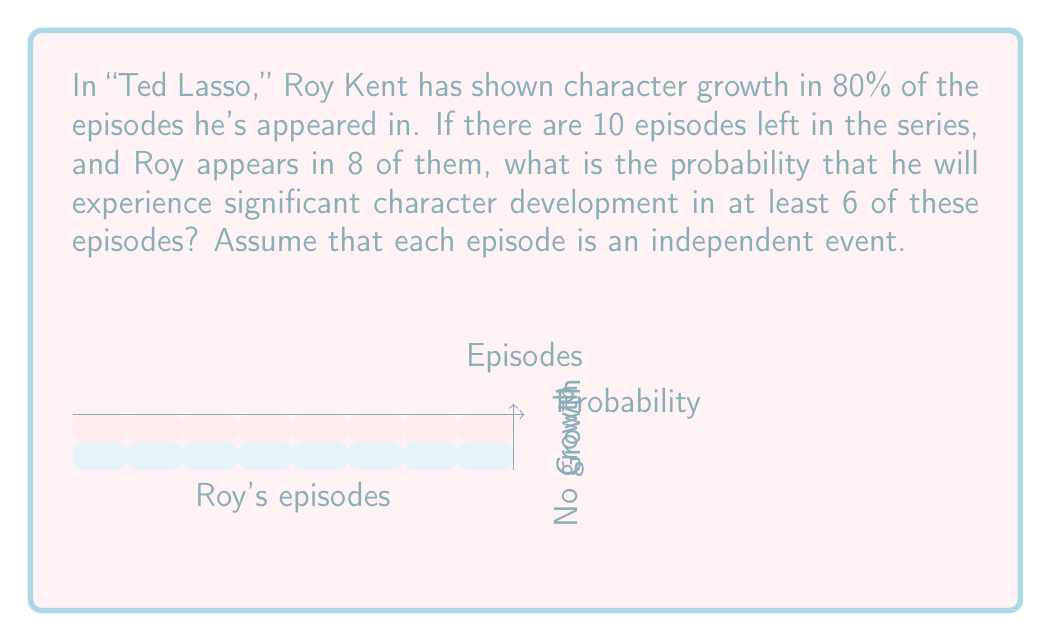Help me with this question. Let's approach this step-by-step using the Binomial distribution:

1) We're dealing with a binomial probability problem where:
   - $n = 8$ (number of episodes Roy appears in)
   - $p = 0.8$ (probability of character growth in each episode)
   - We want at least 6 successes, so we need to calculate $P(X \geq 6)$

2) The probability of at least 6 successes is equal to 1 minus the probability of 5 or fewer successes:

   $P(X \geq 6) = 1 - P(X \leq 5)$

3) Using the binomial probability formula:

   $P(X = k) = \binom{n}{k} p^k (1-p)^{n-k}$

4) We need to sum this for $k = 0$ to $5$:

   $P(X \leq 5) = \sum_{k=0}^5 \binom{8}{k} (0.8)^k (0.2)^{8-k}$

5) Calculating each term:
   $k=0: \binom{8}{0} (0.8)^0 (0.2)^8 = 1 \cdot 1 \cdot 0.00000256 = 0.00000256$
   $k=1: \binom{8}{1} (0.8)^1 (0.2)^7 = 8 \cdot 0.8 \cdot 0.0000128 = 0.00008192$
   $k=2: \binom{8}{2} (0.8)^2 (0.2)^6 = 28 \cdot 0.64 \cdot 0.000064 = 0.00114688$
   $k=3: \binom{8}{3} (0.8)^3 (0.2)^5 = 56 \cdot 0.512 \cdot 0.00032 = 0.00917504$
   $k=4: \binom{8}{4} (0.8)^4 (0.2)^4 = 70 \cdot 0.4096 \cdot 0.0016 = 0.04587520$
   $k=5: \binom{8}{5} (0.8)^5 (0.2)^3 = 56 \cdot 0.32768 \cdot 0.008 = 0.14680064$

6) Sum these probabilities:
   $P(X \leq 5) = 0.20308224$

7) Therefore:
   $P(X \geq 6) = 1 - 0.20308224 = 0.79691776$
Answer: 0.7969 (or approximately 79.69%) 